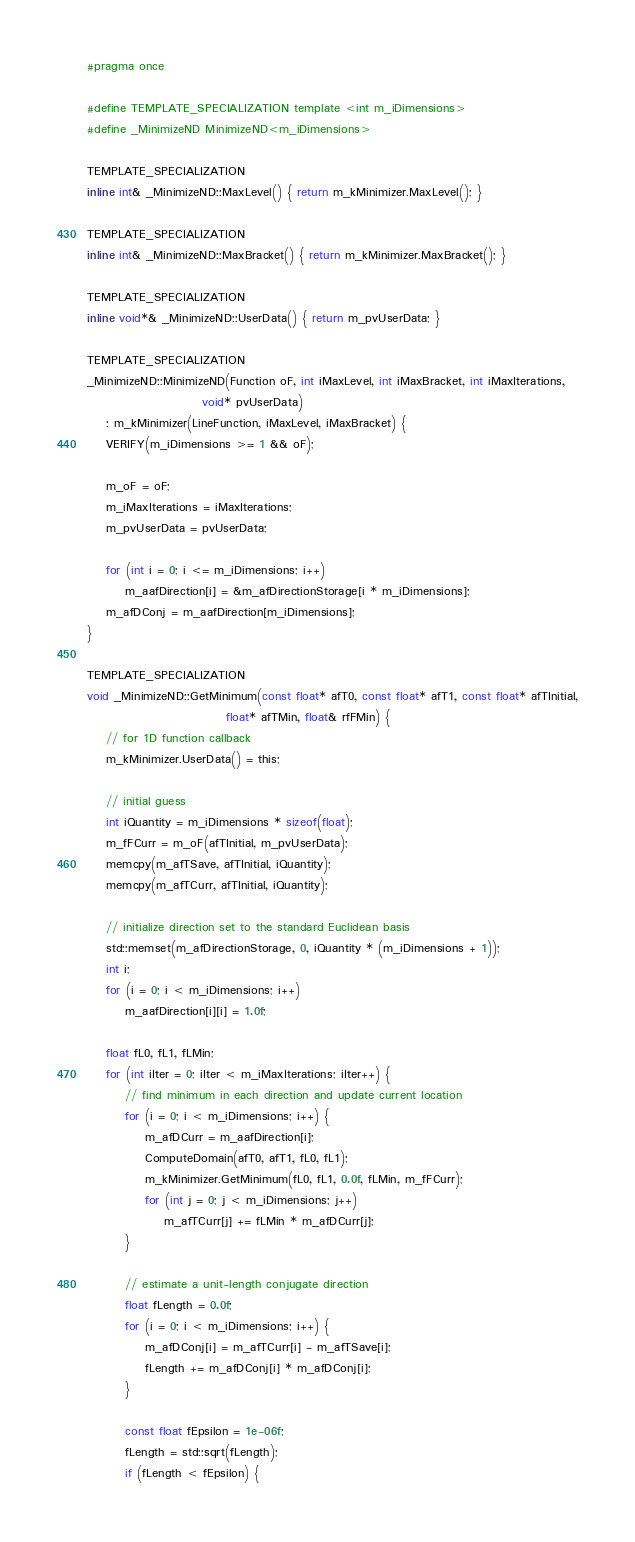Convert code to text. <code><loc_0><loc_0><loc_500><loc_500><_C_>#pragma once

#define TEMPLATE_SPECIALIZATION template <int m_iDimensions>
#define _MinimizeND MinimizeND<m_iDimensions>

TEMPLATE_SPECIALIZATION
inline int& _MinimizeND::MaxLevel() { return m_kMinimizer.MaxLevel(); }

TEMPLATE_SPECIALIZATION
inline int& _MinimizeND::MaxBracket() { return m_kMinimizer.MaxBracket(); }

TEMPLATE_SPECIALIZATION
inline void*& _MinimizeND::UserData() { return m_pvUserData; }

TEMPLATE_SPECIALIZATION
_MinimizeND::MinimizeND(Function oF, int iMaxLevel, int iMaxBracket, int iMaxIterations,
                        void* pvUserData)
    : m_kMinimizer(LineFunction, iMaxLevel, iMaxBracket) {
    VERIFY(m_iDimensions >= 1 && oF);

    m_oF = oF;
    m_iMaxIterations = iMaxIterations;
    m_pvUserData = pvUserData;

    for (int i = 0; i <= m_iDimensions; i++)
        m_aafDirection[i] = &m_afDirectionStorage[i * m_iDimensions];
    m_afDConj = m_aafDirection[m_iDimensions];
}

TEMPLATE_SPECIALIZATION
void _MinimizeND::GetMinimum(const float* afT0, const float* afT1, const float* afTInitial,
                             float* afTMin, float& rfFMin) {
    // for 1D function callback
    m_kMinimizer.UserData() = this;

    // initial guess
    int iQuantity = m_iDimensions * sizeof(float);
    m_fFCurr = m_oF(afTInitial, m_pvUserData);
    memcpy(m_afTSave, afTInitial, iQuantity);
    memcpy(m_afTCurr, afTInitial, iQuantity);

    // initialize direction set to the standard Euclidean basis
    std::memset(m_afDirectionStorage, 0, iQuantity * (m_iDimensions + 1));
    int i;
    for (i = 0; i < m_iDimensions; i++)
        m_aafDirection[i][i] = 1.0f;

    float fL0, fL1, fLMin;
    for (int iIter = 0; iIter < m_iMaxIterations; iIter++) {
        // find minimum in each direction and update current location
        for (i = 0; i < m_iDimensions; i++) {
            m_afDCurr = m_aafDirection[i];
            ComputeDomain(afT0, afT1, fL0, fL1);
            m_kMinimizer.GetMinimum(fL0, fL1, 0.0f, fLMin, m_fFCurr);
            for (int j = 0; j < m_iDimensions; j++)
                m_afTCurr[j] += fLMin * m_afDCurr[j];
        }

        // estimate a unit-length conjugate direction
        float fLength = 0.0f;
        for (i = 0; i < m_iDimensions; i++) {
            m_afDConj[i] = m_afTCurr[i] - m_afTSave[i];
            fLength += m_afDConj[i] * m_afDConj[i];
        }

        const float fEpsilon = 1e-06f;
        fLength = std::sqrt(fLength);
        if (fLength < fEpsilon) {</code> 